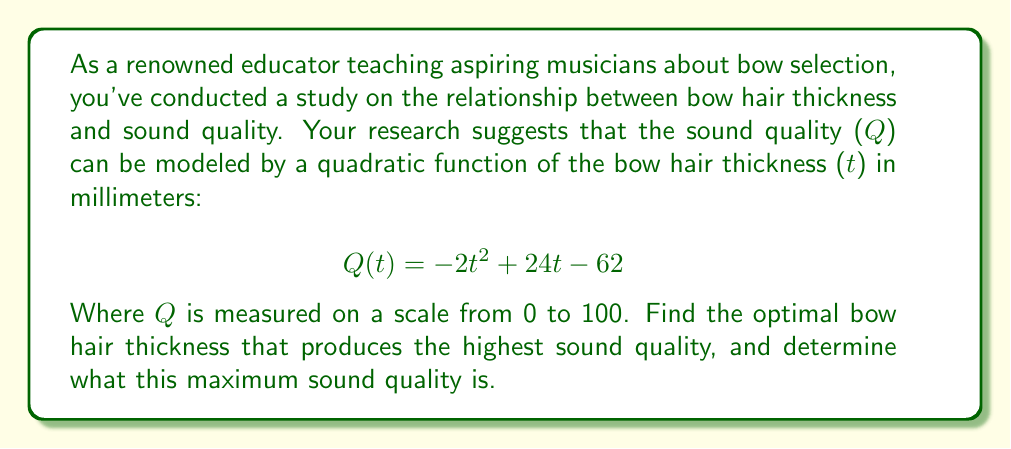Provide a solution to this math problem. To solve this problem, we need to follow these steps:

1) The function $Q(t) = -2t^2 + 24t - 62$ is a quadratic function in the form $f(x) = ax^2 + bx + c$, where $a = -2$, $b = 24$, and $c = -62$.

2) For a quadratic function, the vertex represents either the maximum (if $a < 0$) or minimum (if $a > 0$) point. In this case, since $a = -2 < 0$, the vertex will represent the maximum point.

3) To find the t-coordinate of the vertex, we use the formula: $t = -\frac{b}{2a}$

   $t = -\frac{24}{2(-2)} = -\frac{24}{-4} = 6$

4) This means the optimal bow hair thickness is 6 mm.

5) To find the maximum sound quality, we substitute $t = 6$ into our original function:

   $Q(6) = -2(6)^2 + 24(6) - 62$
   $= -2(36) + 144 - 62$
   $= -72 + 144 - 62$
   $= 10$

Therefore, the maximum sound quality is 10 on a scale from 0 to 100.
Answer: The optimal bow hair thickness is 6 mm, which produces a maximum sound quality of 10 on a scale from 0 to 100. 